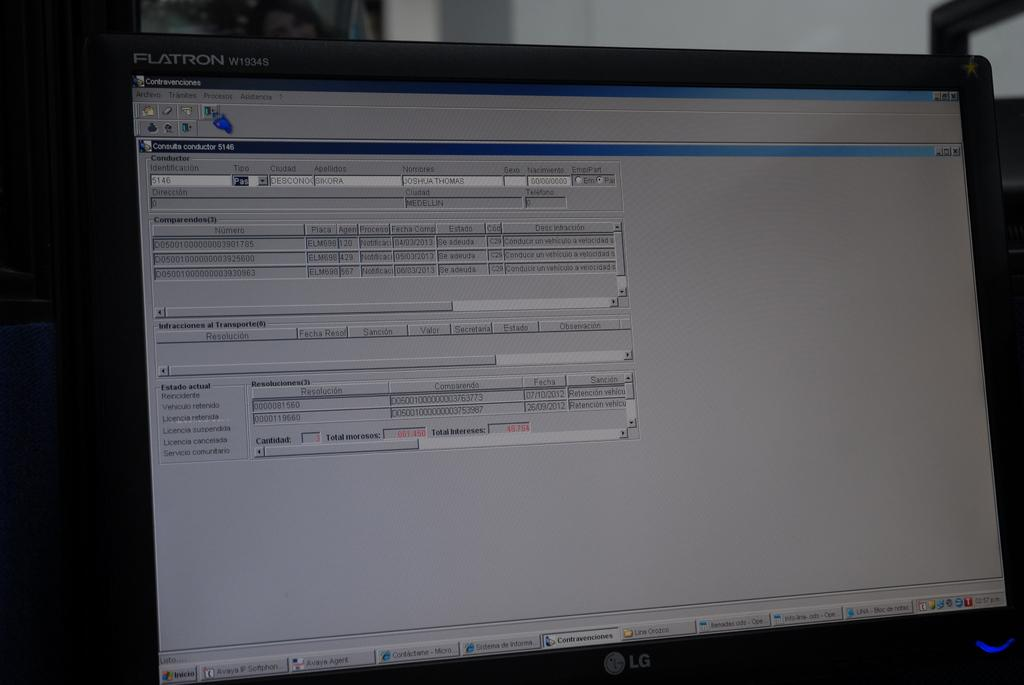<image>
Write a terse but informative summary of the picture. A FLATRON screen with Contravenciones on the top corner 